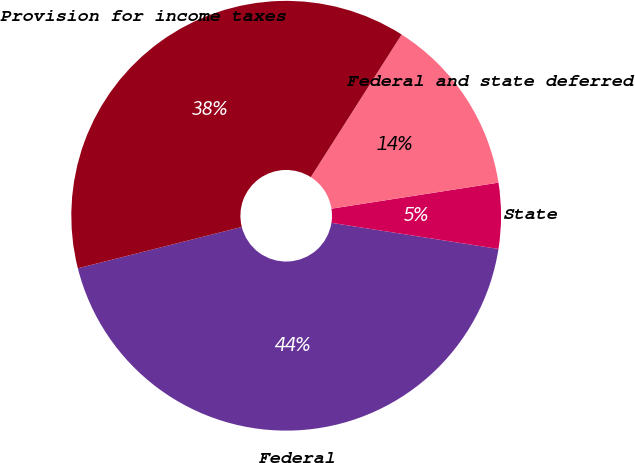Convert chart. <chart><loc_0><loc_0><loc_500><loc_500><pie_chart><fcel>Federal<fcel>State<fcel>Federal and state deferred<fcel>Provision for income taxes<nl><fcel>43.6%<fcel>4.93%<fcel>13.51%<fcel>37.96%<nl></chart> 